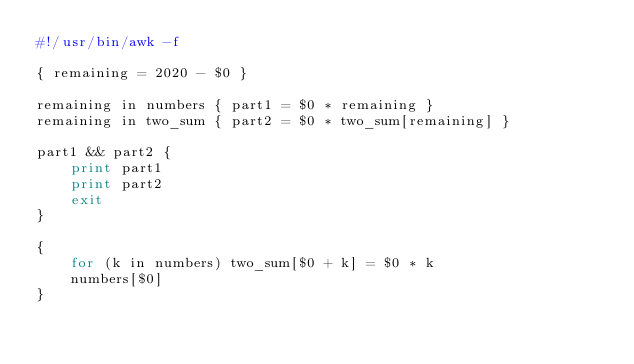<code> <loc_0><loc_0><loc_500><loc_500><_Awk_>#!/usr/bin/awk -f

{ remaining = 2020 - $0 }

remaining in numbers { part1 = $0 * remaining }
remaining in two_sum { part2 = $0 * two_sum[remaining] }

part1 && part2 {
	print part1
	print part2
	exit
}

{
	for (k in numbers) two_sum[$0 + k] = $0 * k
	numbers[$0]
}
</code> 